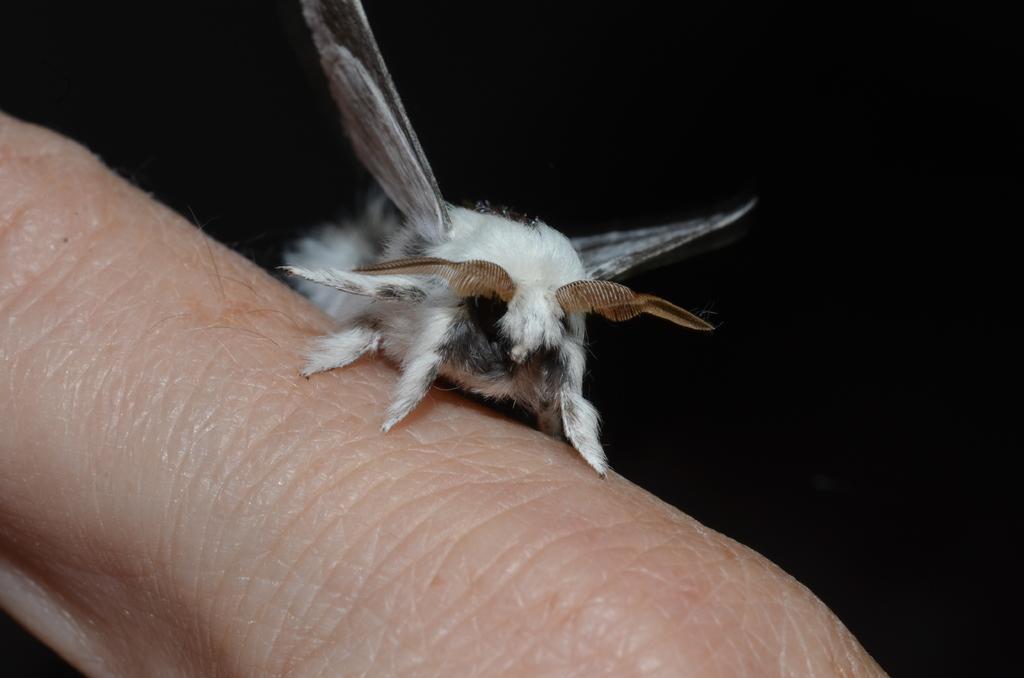In one or two sentences, can you explain what this image depicts? In this image I can see an insect which is white, black and brown in color on the human finger. I can see the black colored background. 